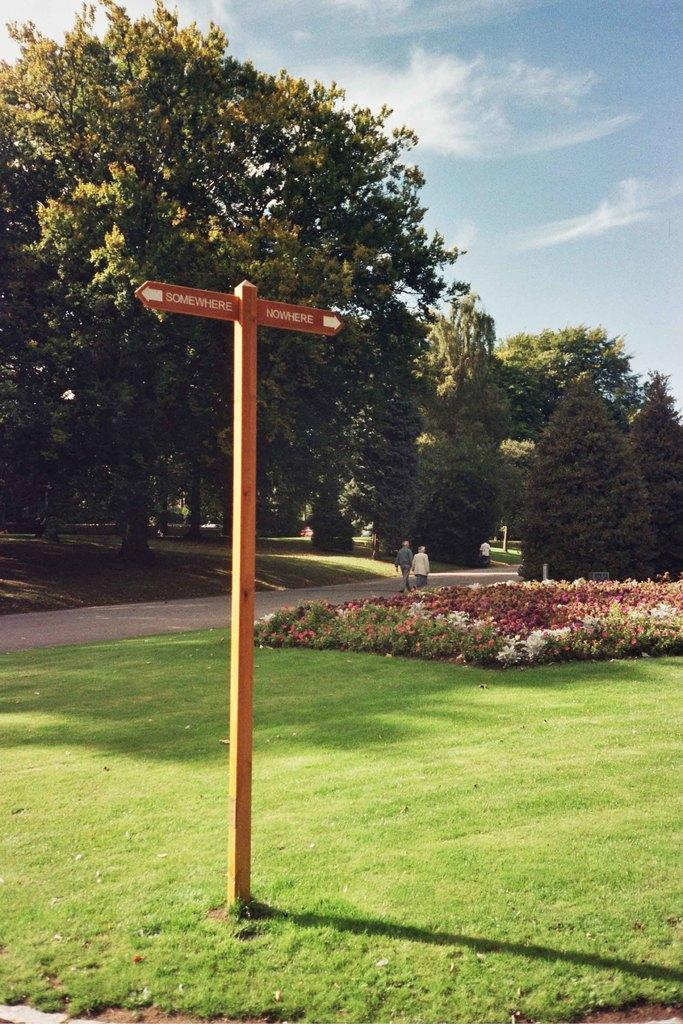What symbol can be seen on the grass in the image? There is a cross sign on the grass in the image. What type of vegetation is on the right side of the image? There are flowers on the right side of the image. What can be seen in the background of the image? Trees are visible in the background of the image. How would you describe the sky in the image? The sky is blue and cloudy in the image. What type of calculator is being used by the judge in the image? There is no judge or calculator present in the image. Can you see any ants crawling on the flowers in the image? There is no mention of ants in the image, so we cannot determine if they are present or not. 